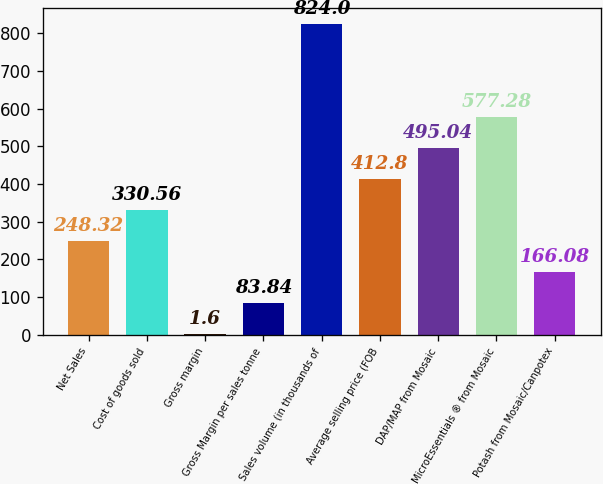Convert chart to OTSL. <chart><loc_0><loc_0><loc_500><loc_500><bar_chart><fcel>Net Sales<fcel>Cost of goods sold<fcel>Gross margin<fcel>Gross Margin per sales tonne<fcel>Sales volume (in thousands of<fcel>Average selling price (FOB<fcel>DAP/MAP from Mosaic<fcel>MicroEssentials ® from Mosaic<fcel>Potash from Mosaic/Canpotex<nl><fcel>248.32<fcel>330.56<fcel>1.6<fcel>83.84<fcel>824<fcel>412.8<fcel>495.04<fcel>577.28<fcel>166.08<nl></chart> 